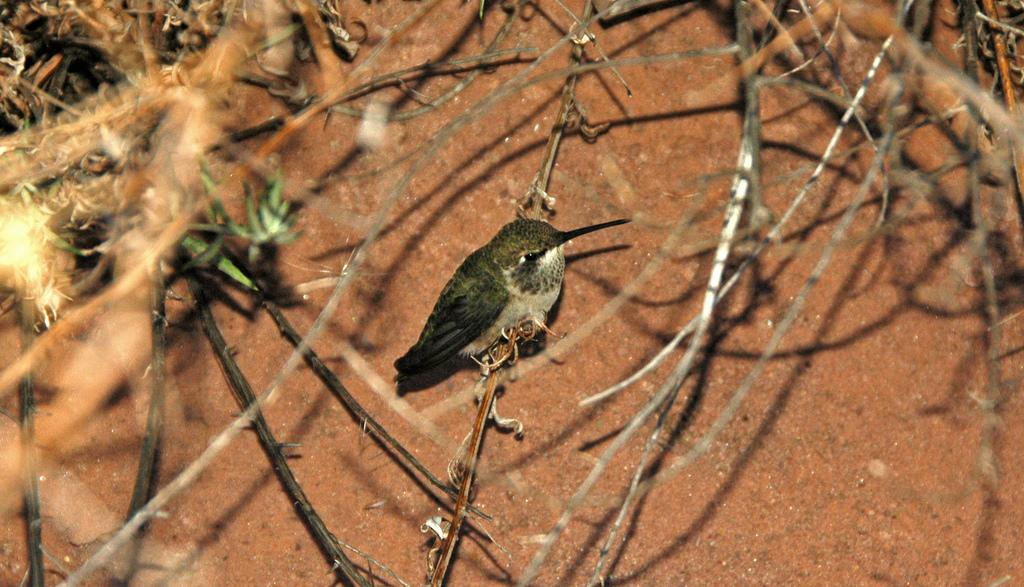What is the main subject of the picture? There is a bird in the center of the picture. Where is the bird located in the image? The bird is sitting on a stem. What can be seen at the top of the image? There are twigs at the top of the image. What type of ground is visible in the background? There is soil visible in the background. What is the weather like in the image? The image appears to be sunny. What type of doll is sitting next to the bird in the image? There is no doll present in the image; it features a bird sitting on a stem. What finger is the bird using to hold the paste in the image? There is no finger or paste present in the image; it only shows a bird sitting on a stem. 